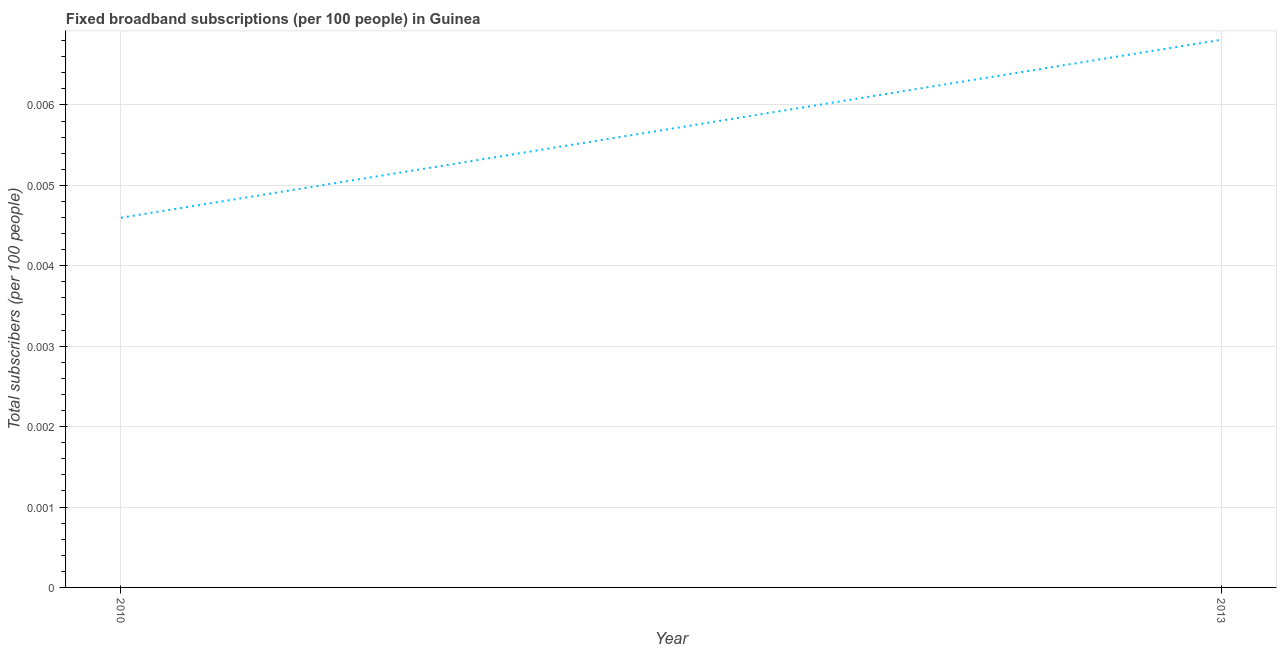What is the total number of fixed broadband subscriptions in 2010?
Ensure brevity in your answer.  0. Across all years, what is the maximum total number of fixed broadband subscriptions?
Offer a terse response. 0.01. Across all years, what is the minimum total number of fixed broadband subscriptions?
Provide a short and direct response. 0. What is the sum of the total number of fixed broadband subscriptions?
Offer a terse response. 0.01. What is the difference between the total number of fixed broadband subscriptions in 2010 and 2013?
Provide a succinct answer. -0. What is the average total number of fixed broadband subscriptions per year?
Provide a succinct answer. 0.01. What is the median total number of fixed broadband subscriptions?
Your answer should be very brief. 0.01. What is the ratio of the total number of fixed broadband subscriptions in 2010 to that in 2013?
Your answer should be very brief. 0.67. Is the total number of fixed broadband subscriptions in 2010 less than that in 2013?
Make the answer very short. Yes. In how many years, is the total number of fixed broadband subscriptions greater than the average total number of fixed broadband subscriptions taken over all years?
Your answer should be compact. 1. How many years are there in the graph?
Ensure brevity in your answer.  2. What is the difference between two consecutive major ticks on the Y-axis?
Your answer should be compact. 0. What is the title of the graph?
Offer a very short reply. Fixed broadband subscriptions (per 100 people) in Guinea. What is the label or title of the X-axis?
Ensure brevity in your answer.  Year. What is the label or title of the Y-axis?
Ensure brevity in your answer.  Total subscribers (per 100 people). What is the Total subscribers (per 100 people) in 2010?
Your answer should be compact. 0. What is the Total subscribers (per 100 people) in 2013?
Ensure brevity in your answer.  0.01. What is the difference between the Total subscribers (per 100 people) in 2010 and 2013?
Your answer should be very brief. -0. What is the ratio of the Total subscribers (per 100 people) in 2010 to that in 2013?
Your answer should be very brief. 0.68. 